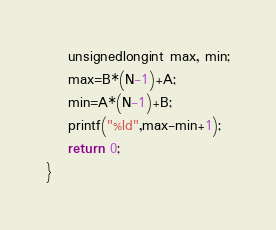Convert code to text. <code><loc_0><loc_0><loc_500><loc_500><_C_>    unsignedlongint max, min;
    max=B*(N-1)+A;
    min=A*(N-1)+B;
    printf("%ld",max-min+1);
    return 0;
}

</code> 